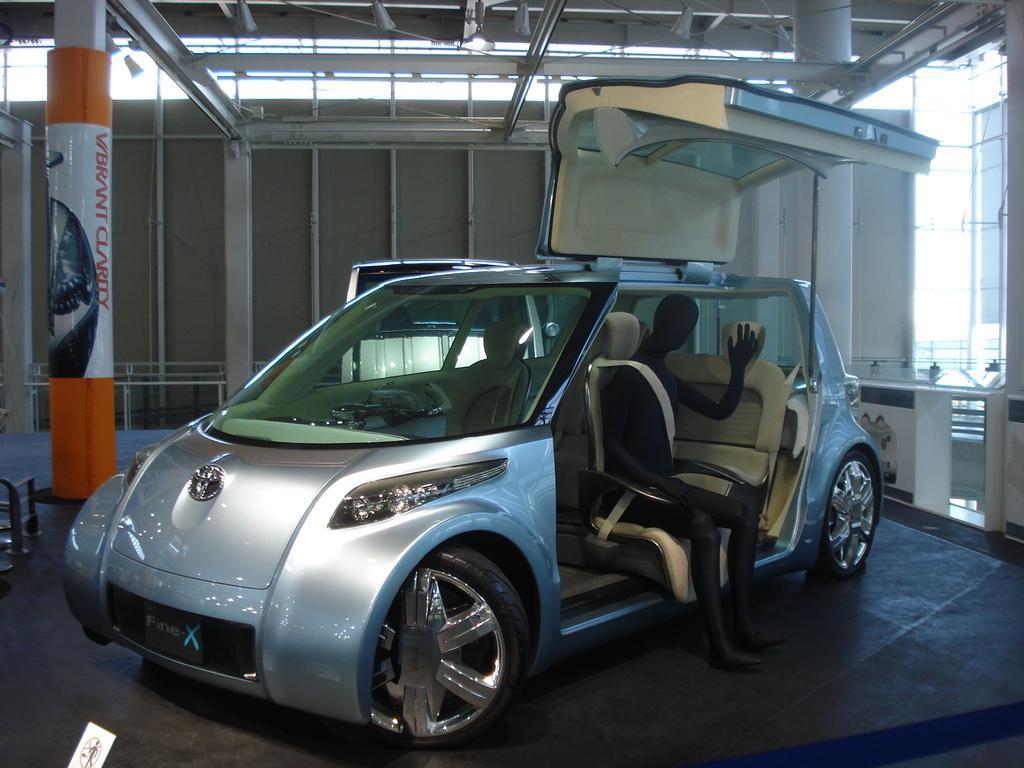In one or two sentences, can you explain what this image depicts? In the center of the image there is a car. There is a depiction of a person sitting on the car. Behind the car there are pillars. At the bottom of the image there is a floor. On the right side of the image there is a glass window. On top of the image there is a light. 